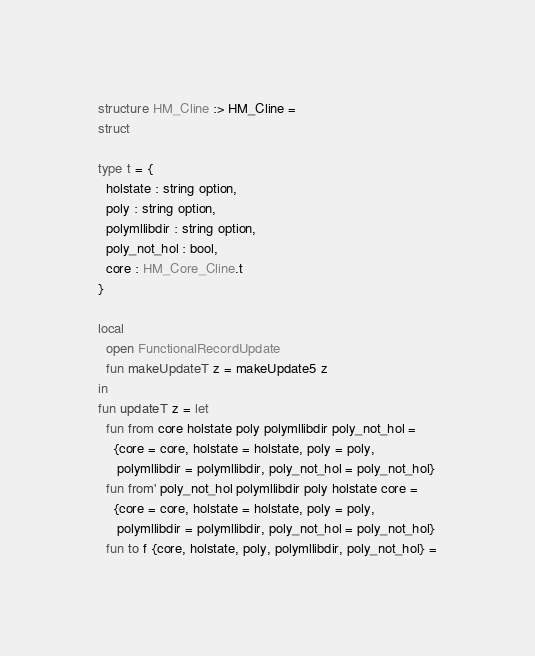<code> <loc_0><loc_0><loc_500><loc_500><_SML_>structure HM_Cline :> HM_Cline =
struct

type t = {
  holstate : string option,
  poly : string option,
  polymllibdir : string option,
  poly_not_hol : bool,
  core : HM_Core_Cline.t
}

local
  open FunctionalRecordUpdate
  fun makeUpdateT z = makeUpdate5 z
in
fun updateT z = let
  fun from core holstate poly polymllibdir poly_not_hol =
    {core = core, holstate = holstate, poly = poly,
     polymllibdir = polymllibdir, poly_not_hol = poly_not_hol}
  fun from' poly_not_hol polymllibdir poly holstate core =
    {core = core, holstate = holstate, poly = poly,
     polymllibdir = polymllibdir, poly_not_hol = poly_not_hol}
  fun to f {core, holstate, poly, polymllibdir, poly_not_hol} =</code> 